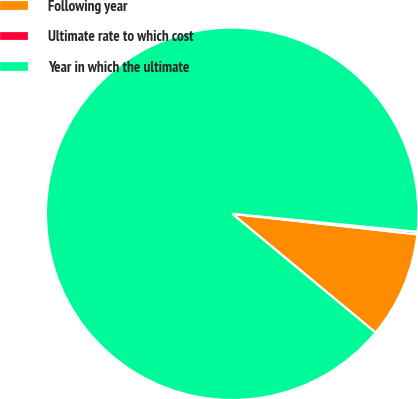<chart> <loc_0><loc_0><loc_500><loc_500><pie_chart><fcel>Following year<fcel>Ultimate rate to which cost<fcel>Year in which the ultimate<nl><fcel>9.25%<fcel>0.22%<fcel>90.52%<nl></chart> 